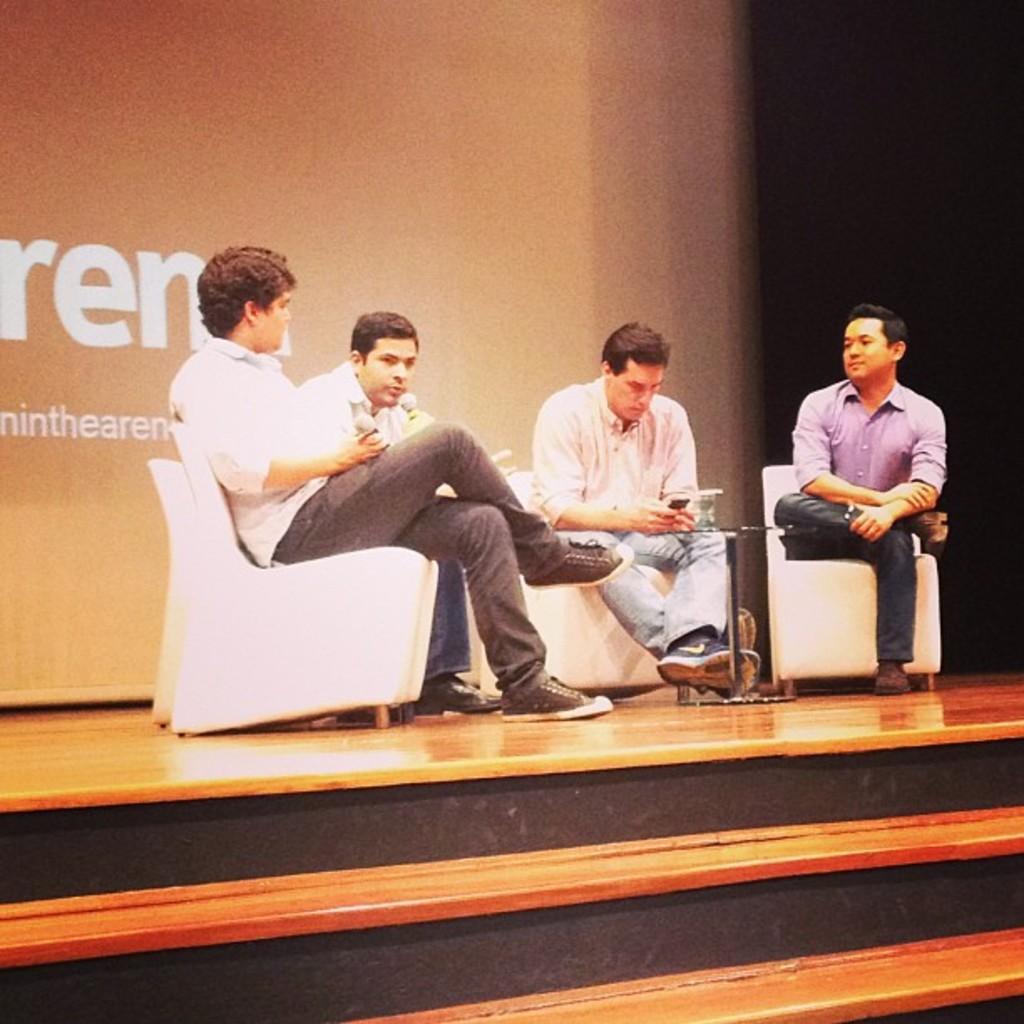In one or two sentences, can you explain what this image depicts? There are four persons sitting on the chairs and they are holding mike's. This is floor. In the background we can see a banner. 